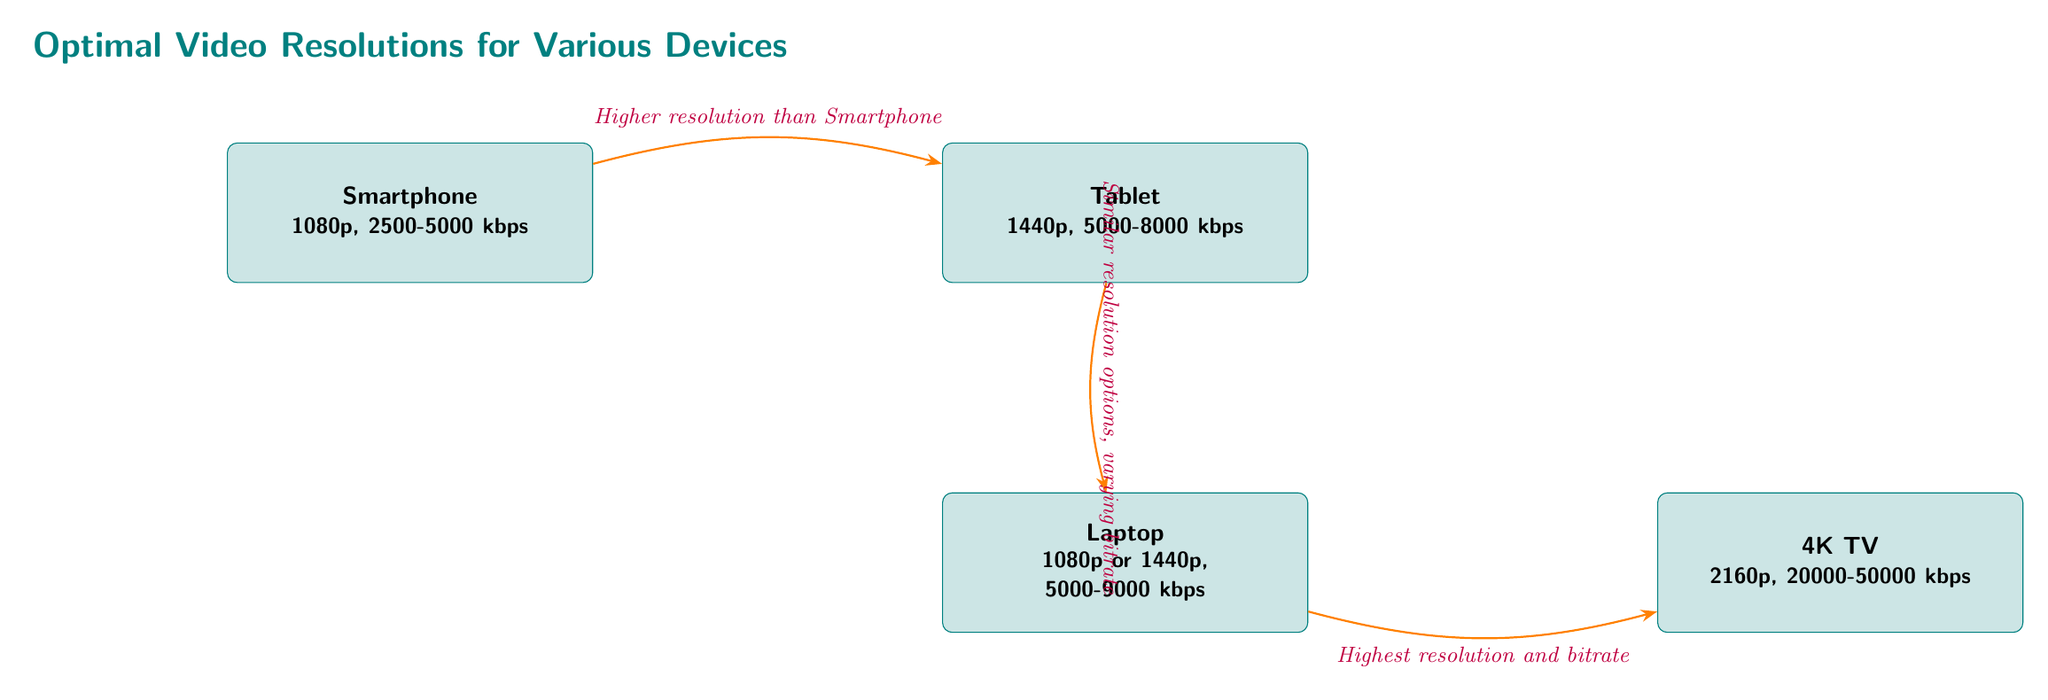What's the recommended resolution for a smartphone? The diagram specifies that the recommended resolution for a smartphone is 1080p.
Answer: 1080p What is the bitrate range for tablet video? According to the diagram, the bitrate range for tablet video is 5000-8000 kbps.
Answer: 5000-8000 kbps How many devices are represented in the diagram? The diagram includes four devices: smartphone, tablet, laptop, and 4K TV, so there are four devices in total.
Answer: 4 What is the highest resolution device shown? From the diagram, the highest resolution device is the 4K TV, which has a resolution of 2160p.
Answer: 2160p What relationship is indicated between the tablet and the laptop? The diagram shows that the relationship between the tablet and the laptop is that they have similar resolution options, but varying bitrate.
Answer: Similar resolution options, varying bitrate What is the bitrate range for the 4K TV? The diagram clearly states that the bitrate range for the 4K TV is 20000-50000 kbps.
Answer: 20000-50000 kbps Which device has both 1080p and 1440p options? The laptop is shown in the diagram as having both 1080p and 1440p resolution options.
Answer: Laptop Which device is directly connected to the smartphone? The tablet is directly connected to the smartphone, indicating a relationship in resolution choices.
Answer: Tablet What does the arrow from the smartphone to the tablet indicate? The arrow from the smartphone to the tablet indicates a higher resolution than the smartphone.
Answer: Higher resolution than Smartphone 